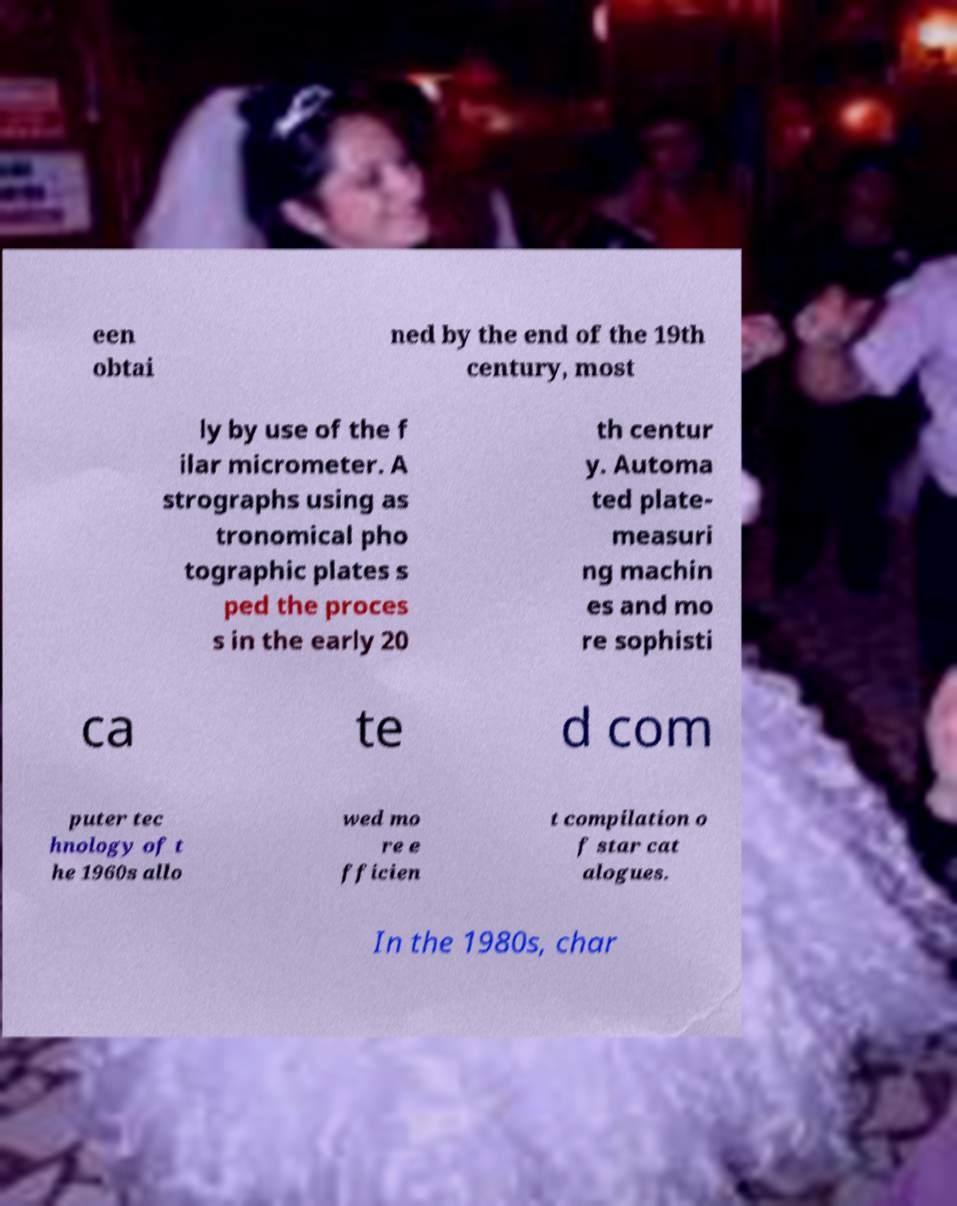Please identify and transcribe the text found in this image. een obtai ned by the end of the 19th century, most ly by use of the f ilar micrometer. A strographs using as tronomical pho tographic plates s ped the proces s in the early 20 th centur y. Automa ted plate- measuri ng machin es and mo re sophisti ca te d com puter tec hnology of t he 1960s allo wed mo re e fficien t compilation o f star cat alogues. In the 1980s, char 